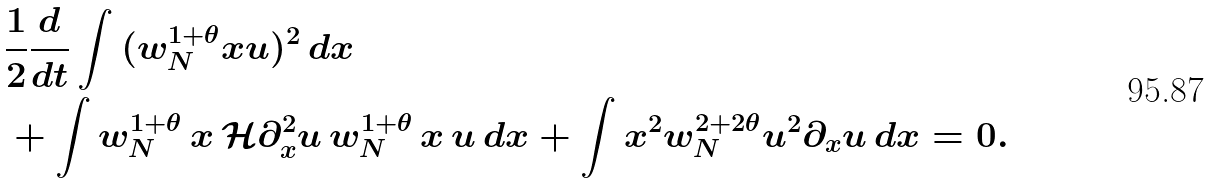Convert formula to latex. <formula><loc_0><loc_0><loc_500><loc_500>& \frac { 1 } { 2 } \frac { d } { d t } \int { ( w _ { N } ^ { 1 + \theta } x u ) ^ { 2 } \, d x } \\ & + \int { w _ { N } ^ { 1 + \theta } \, x \, \mathcal { H } \partial _ { x } ^ { 2 } u \, w _ { N } ^ { 1 + \theta } \, x \, u \, d x } + \int { x ^ { 2 } w _ { N } ^ { 2 + 2 \theta } u ^ { 2 } \partial _ { x } u \, d x } = 0 .</formula> 